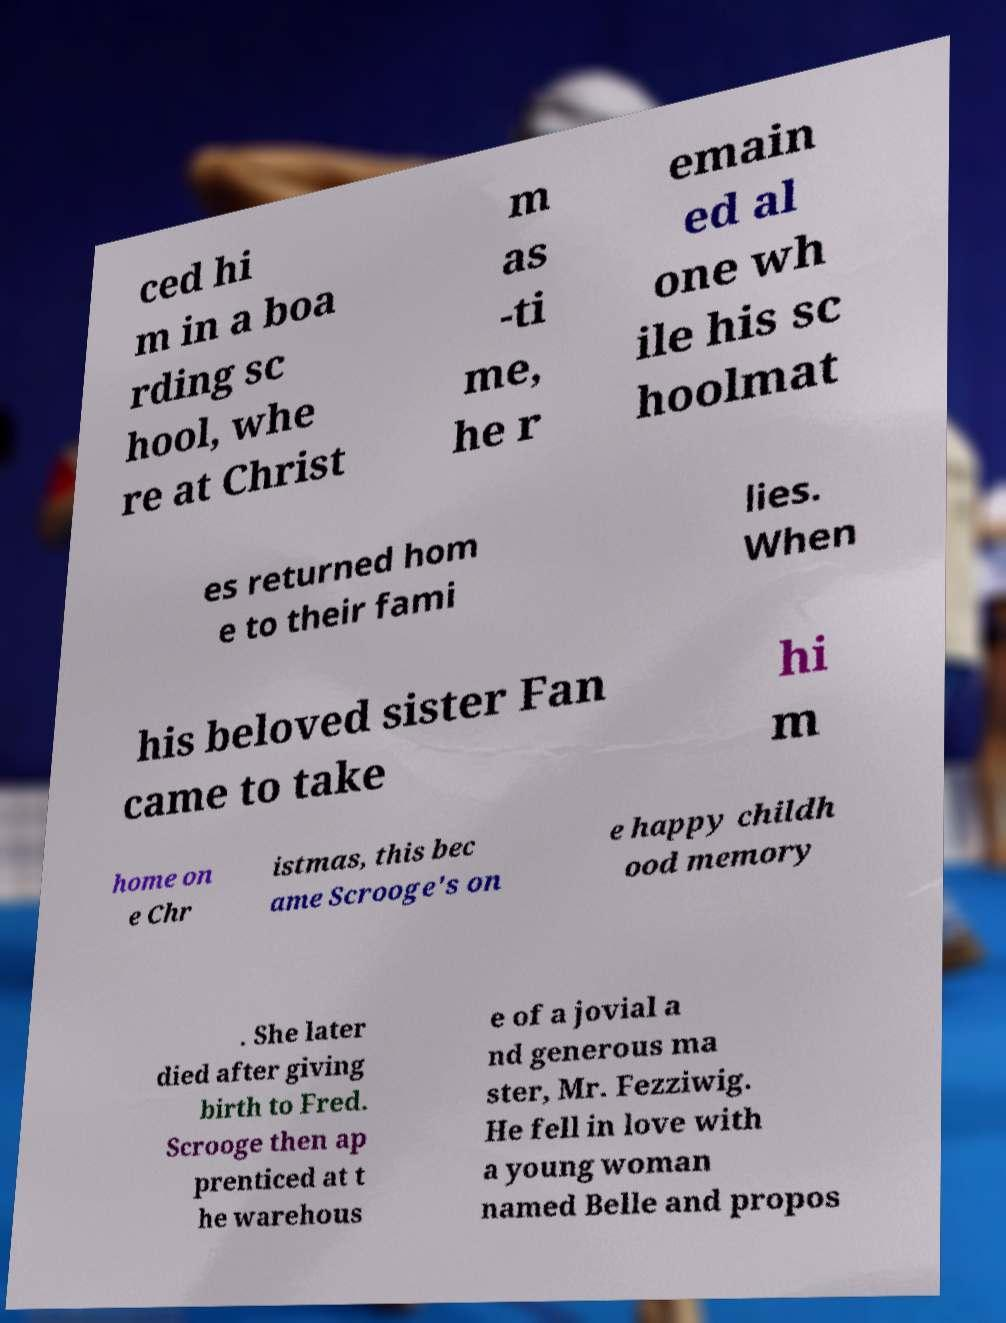Please identify and transcribe the text found in this image. ced hi m in a boa rding sc hool, whe re at Christ m as -ti me, he r emain ed al one wh ile his sc hoolmat es returned hom e to their fami lies. When his beloved sister Fan came to take hi m home on e Chr istmas, this bec ame Scrooge's on e happy childh ood memory . She later died after giving birth to Fred. Scrooge then ap prenticed at t he warehous e of a jovial a nd generous ma ster, Mr. Fezziwig. He fell in love with a young woman named Belle and propos 